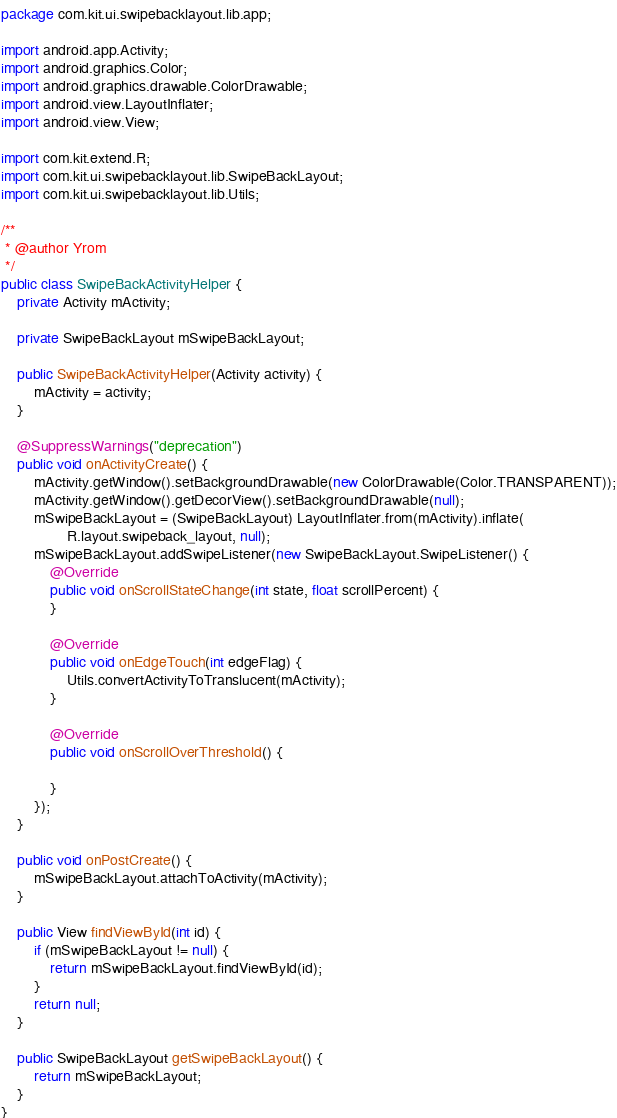<code> <loc_0><loc_0><loc_500><loc_500><_Java_>package com.kit.ui.swipebacklayout.lib.app;

import android.app.Activity;
import android.graphics.Color;
import android.graphics.drawable.ColorDrawable;
import android.view.LayoutInflater;
import android.view.View;

import com.kit.extend.R;
import com.kit.ui.swipebacklayout.lib.SwipeBackLayout;
import com.kit.ui.swipebacklayout.lib.Utils;

/**
 * @author Yrom
 */
public class SwipeBackActivityHelper {
    private Activity mActivity;

    private SwipeBackLayout mSwipeBackLayout;

    public SwipeBackActivityHelper(Activity activity) {
        mActivity = activity;
    }

    @SuppressWarnings("deprecation")
    public void onActivityCreate() {
        mActivity.getWindow().setBackgroundDrawable(new ColorDrawable(Color.TRANSPARENT));
        mActivity.getWindow().getDecorView().setBackgroundDrawable(null);
        mSwipeBackLayout = (SwipeBackLayout) LayoutInflater.from(mActivity).inflate(
                R.layout.swipeback_layout, null);
        mSwipeBackLayout.addSwipeListener(new SwipeBackLayout.SwipeListener() {
            @Override
            public void onScrollStateChange(int state, float scrollPercent) {
            }

            @Override
            public void onEdgeTouch(int edgeFlag) {
                Utils.convertActivityToTranslucent(mActivity);
            }

            @Override
            public void onScrollOverThreshold() {

            }
        });
    }

    public void onPostCreate() {
        mSwipeBackLayout.attachToActivity(mActivity);
    }

    public View findViewById(int id) {
        if (mSwipeBackLayout != null) {
            return mSwipeBackLayout.findViewById(id);
        }
        return null;
    }

    public SwipeBackLayout getSwipeBackLayout() {
        return mSwipeBackLayout;
    }
}
</code> 